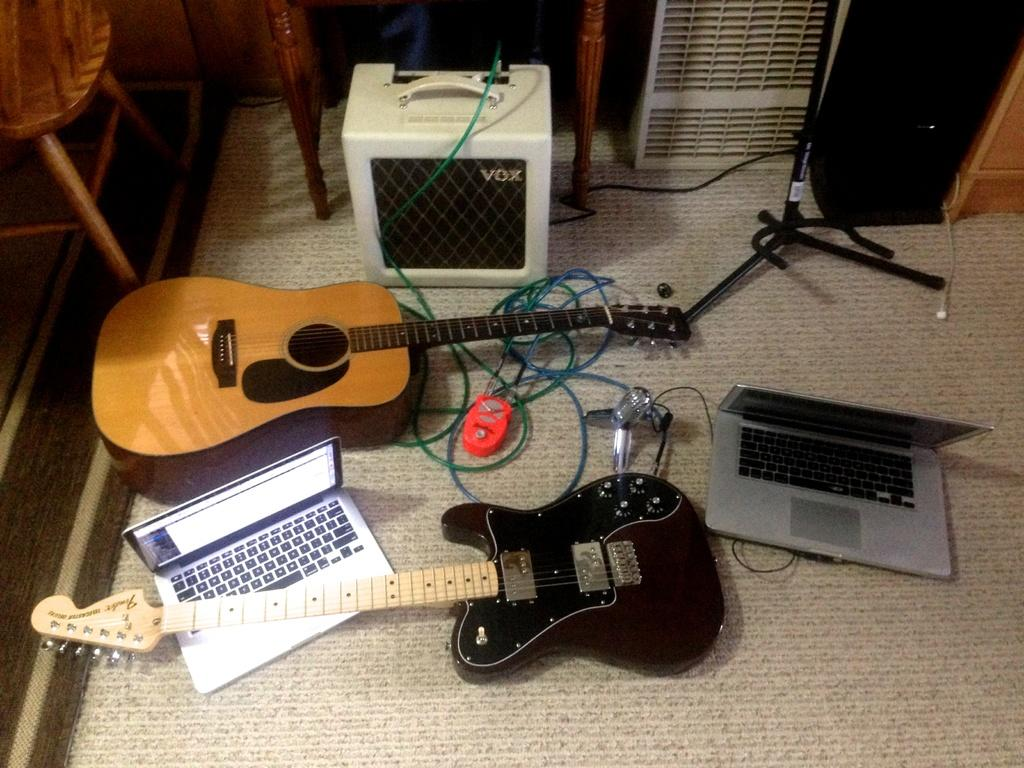What musical instruments are on the floor in the image? There are two guitars on the floor. What electronic devices are on the floor in the image? There are two laptops on the floor. What audio equipment is on the floor in the image? There are two sound boxes on the floor. What part of the human body is visible on the floor in the image? There is no human body part visible on the floor in the image. What type of parcel can be seen on the floor in the image? There is no parcel present on the floor in the image. 